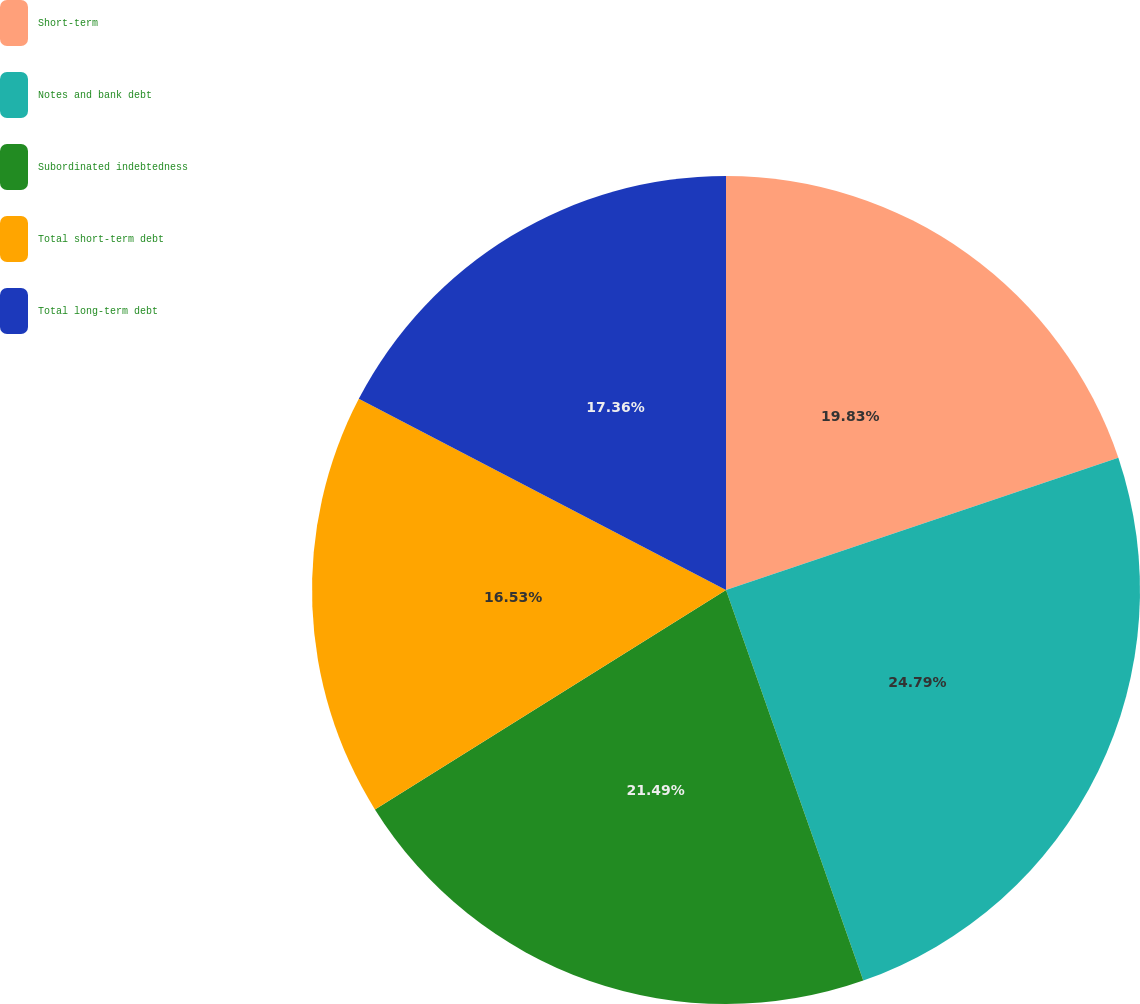Convert chart. <chart><loc_0><loc_0><loc_500><loc_500><pie_chart><fcel>Short-term<fcel>Notes and bank debt<fcel>Subordinated indebtedness<fcel>Total short-term debt<fcel>Total long-term debt<nl><fcel>19.83%<fcel>24.79%<fcel>21.49%<fcel>16.53%<fcel>17.36%<nl></chart> 